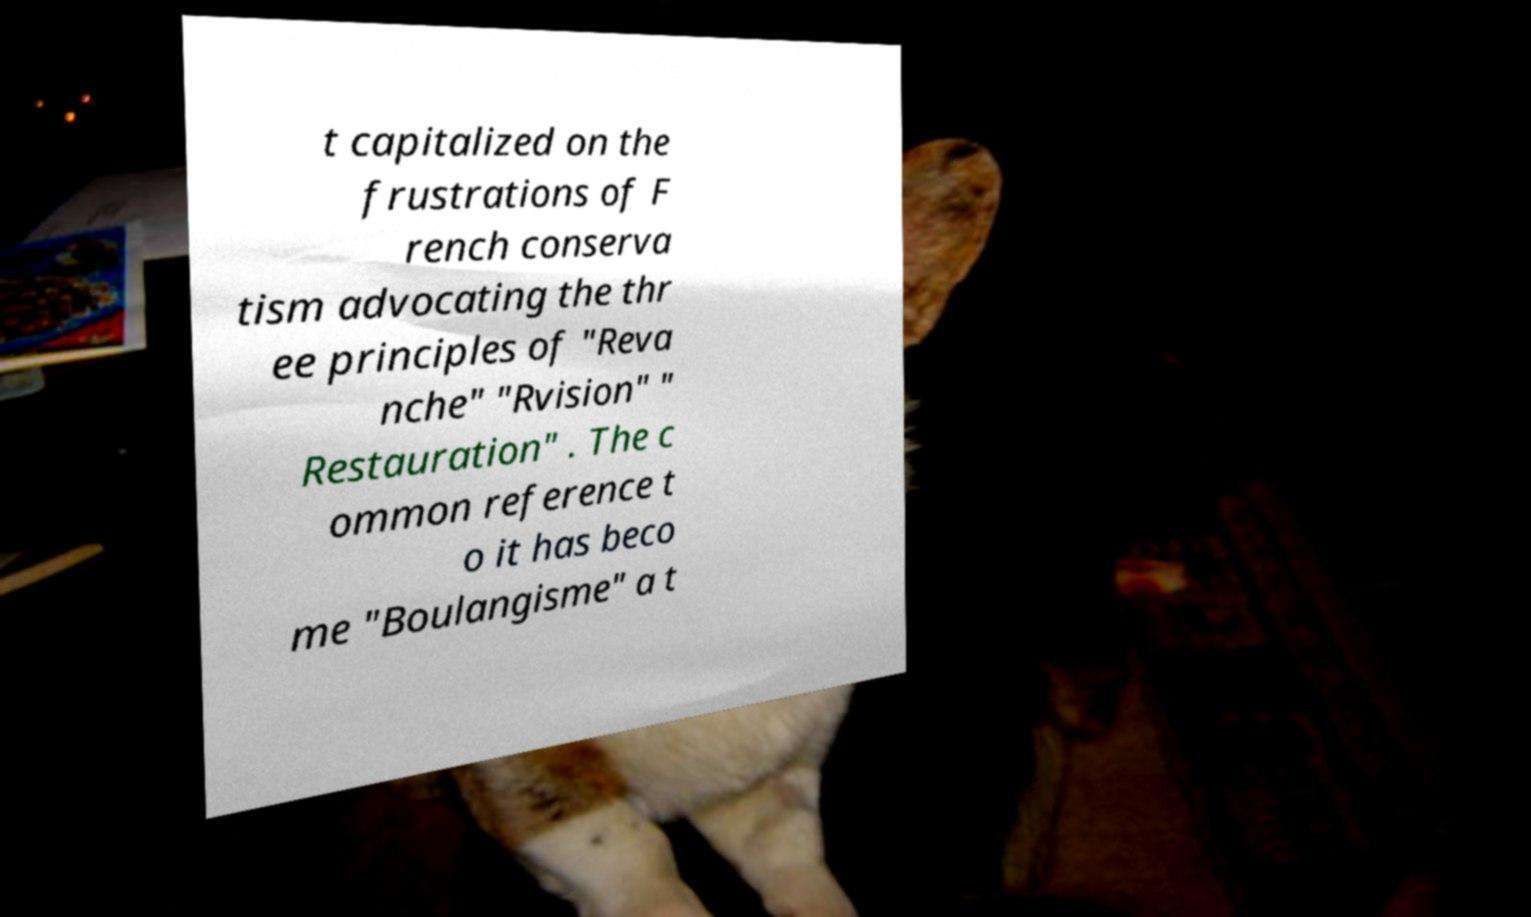Can you accurately transcribe the text from the provided image for me? t capitalized on the frustrations of F rench conserva tism advocating the thr ee principles of "Reva nche" "Rvision" " Restauration" . The c ommon reference t o it has beco me "Boulangisme" a t 